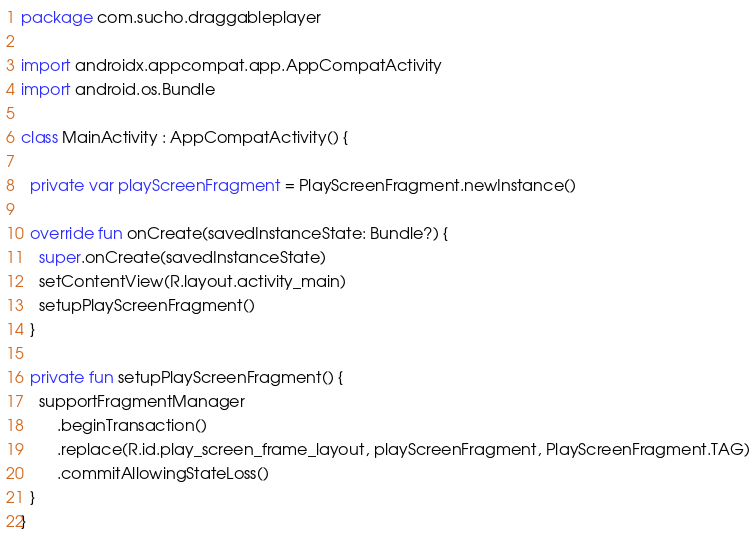<code> <loc_0><loc_0><loc_500><loc_500><_Kotlin_>package com.sucho.draggableplayer

import androidx.appcompat.app.AppCompatActivity
import android.os.Bundle

class MainActivity : AppCompatActivity() {

  private var playScreenFragment = PlayScreenFragment.newInstance()

  override fun onCreate(savedInstanceState: Bundle?) {
    super.onCreate(savedInstanceState)
    setContentView(R.layout.activity_main)
    setupPlayScreenFragment()
  }

  private fun setupPlayScreenFragment() {
    supportFragmentManager
        .beginTransaction()
        .replace(R.id.play_screen_frame_layout, playScreenFragment, PlayScreenFragment.TAG)
        .commitAllowingStateLoss()
  }
}</code> 